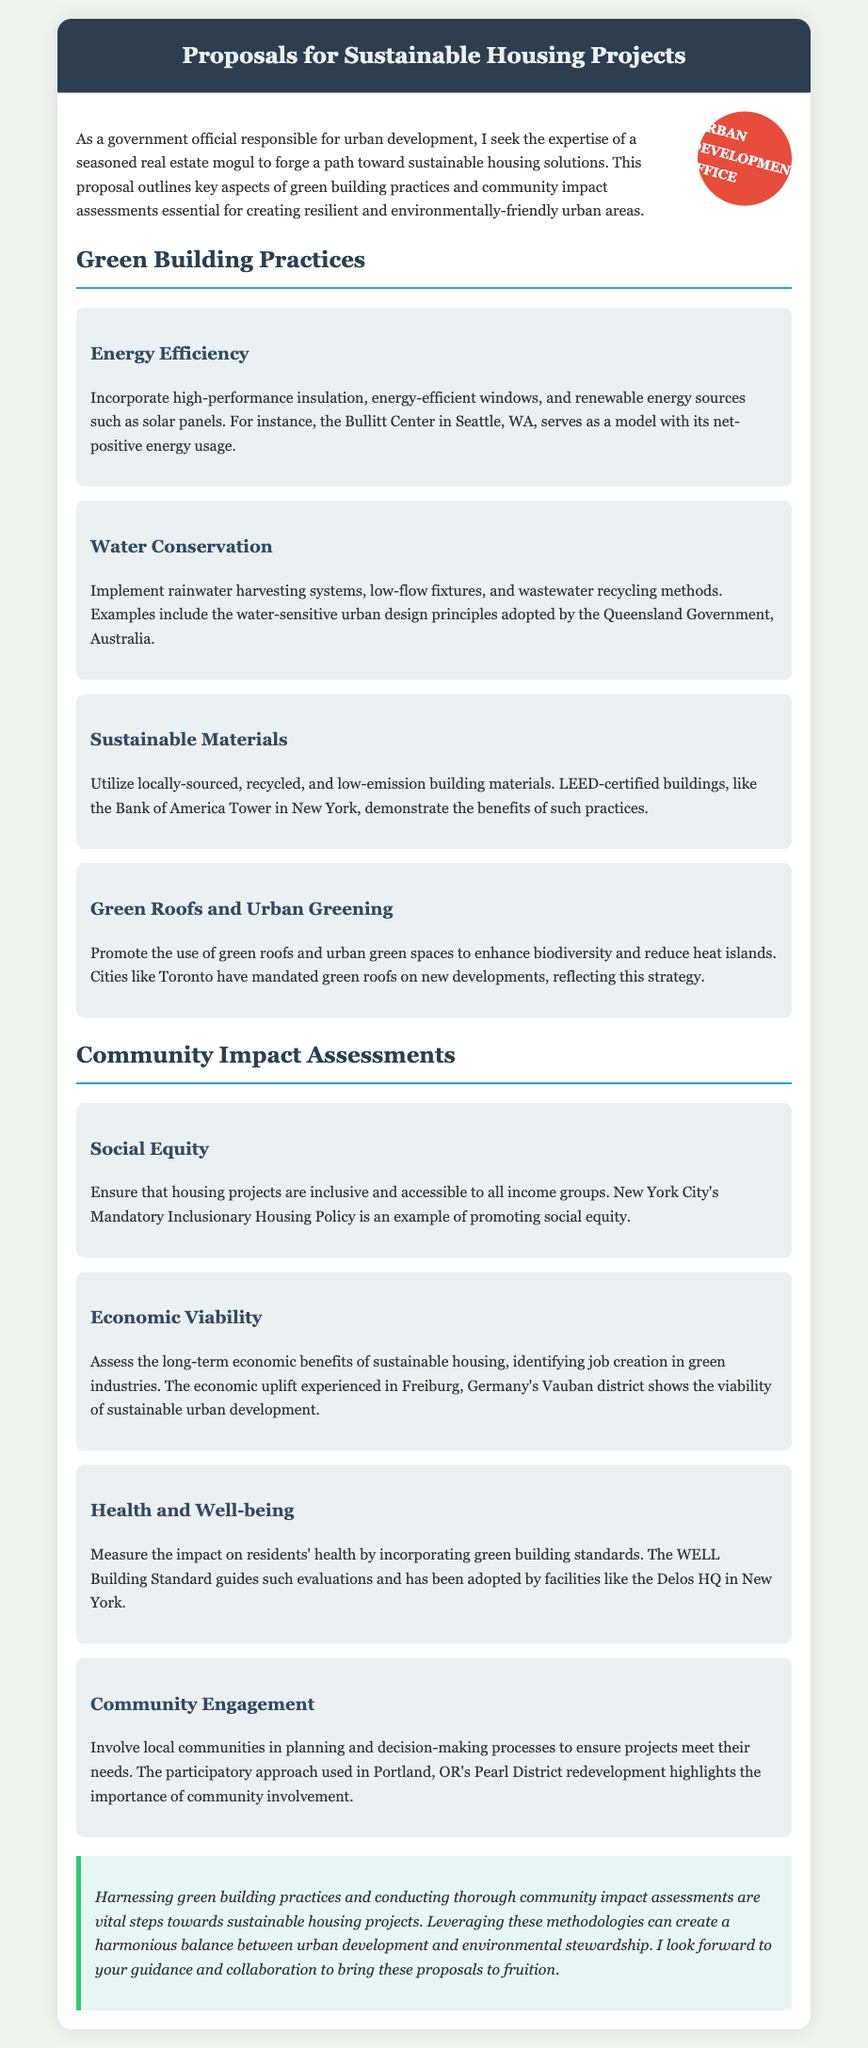What is the main title of the document? The main title is prominently displayed at the top of the document.
Answer: Proposals for Sustainable Housing Projects What city is mentioned as an example of a model for energy efficiency? The document provides a specific model for energy efficiency in a named city.
Answer: Seattle What practice involves the use of low-flow fixtures? This practice is mentioned under a subsection related to conserving specific resources in sustainable housing.
Answer: Water Conservation Which building standard was adopted by the Delos HQ for health assessments? The document identifies a specific standard related to health in buildings.
Answer: WELL Building Standard What is the focus of the community engagement mentioned? This aspect emphasizes the inclusivity of housing projects and community involvement.
Answer: Planning and decision-making processes How many green building practices are listed in the document? The number of practices can be counted by reviewing the sections in the document related to green building.
Answer: Four What is the key methodology highlighted for sustainable housing projects? The document emphasizes an important approach to ensure environmental stewardship.
Answer: Green building practices Which district in Germany is cited as an example of economic viability in sustainable housing? The document provides a specific example of a district that illustrates the economic benefits of urban development.
Answer: Vauban What color is used for the header of the document? The color associated with the header can be identified by examining the document's styling.
Answer: Dark blue 